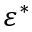Convert formula to latex. <formula><loc_0><loc_0><loc_500><loc_500>\varepsilon ^ { * }</formula> 